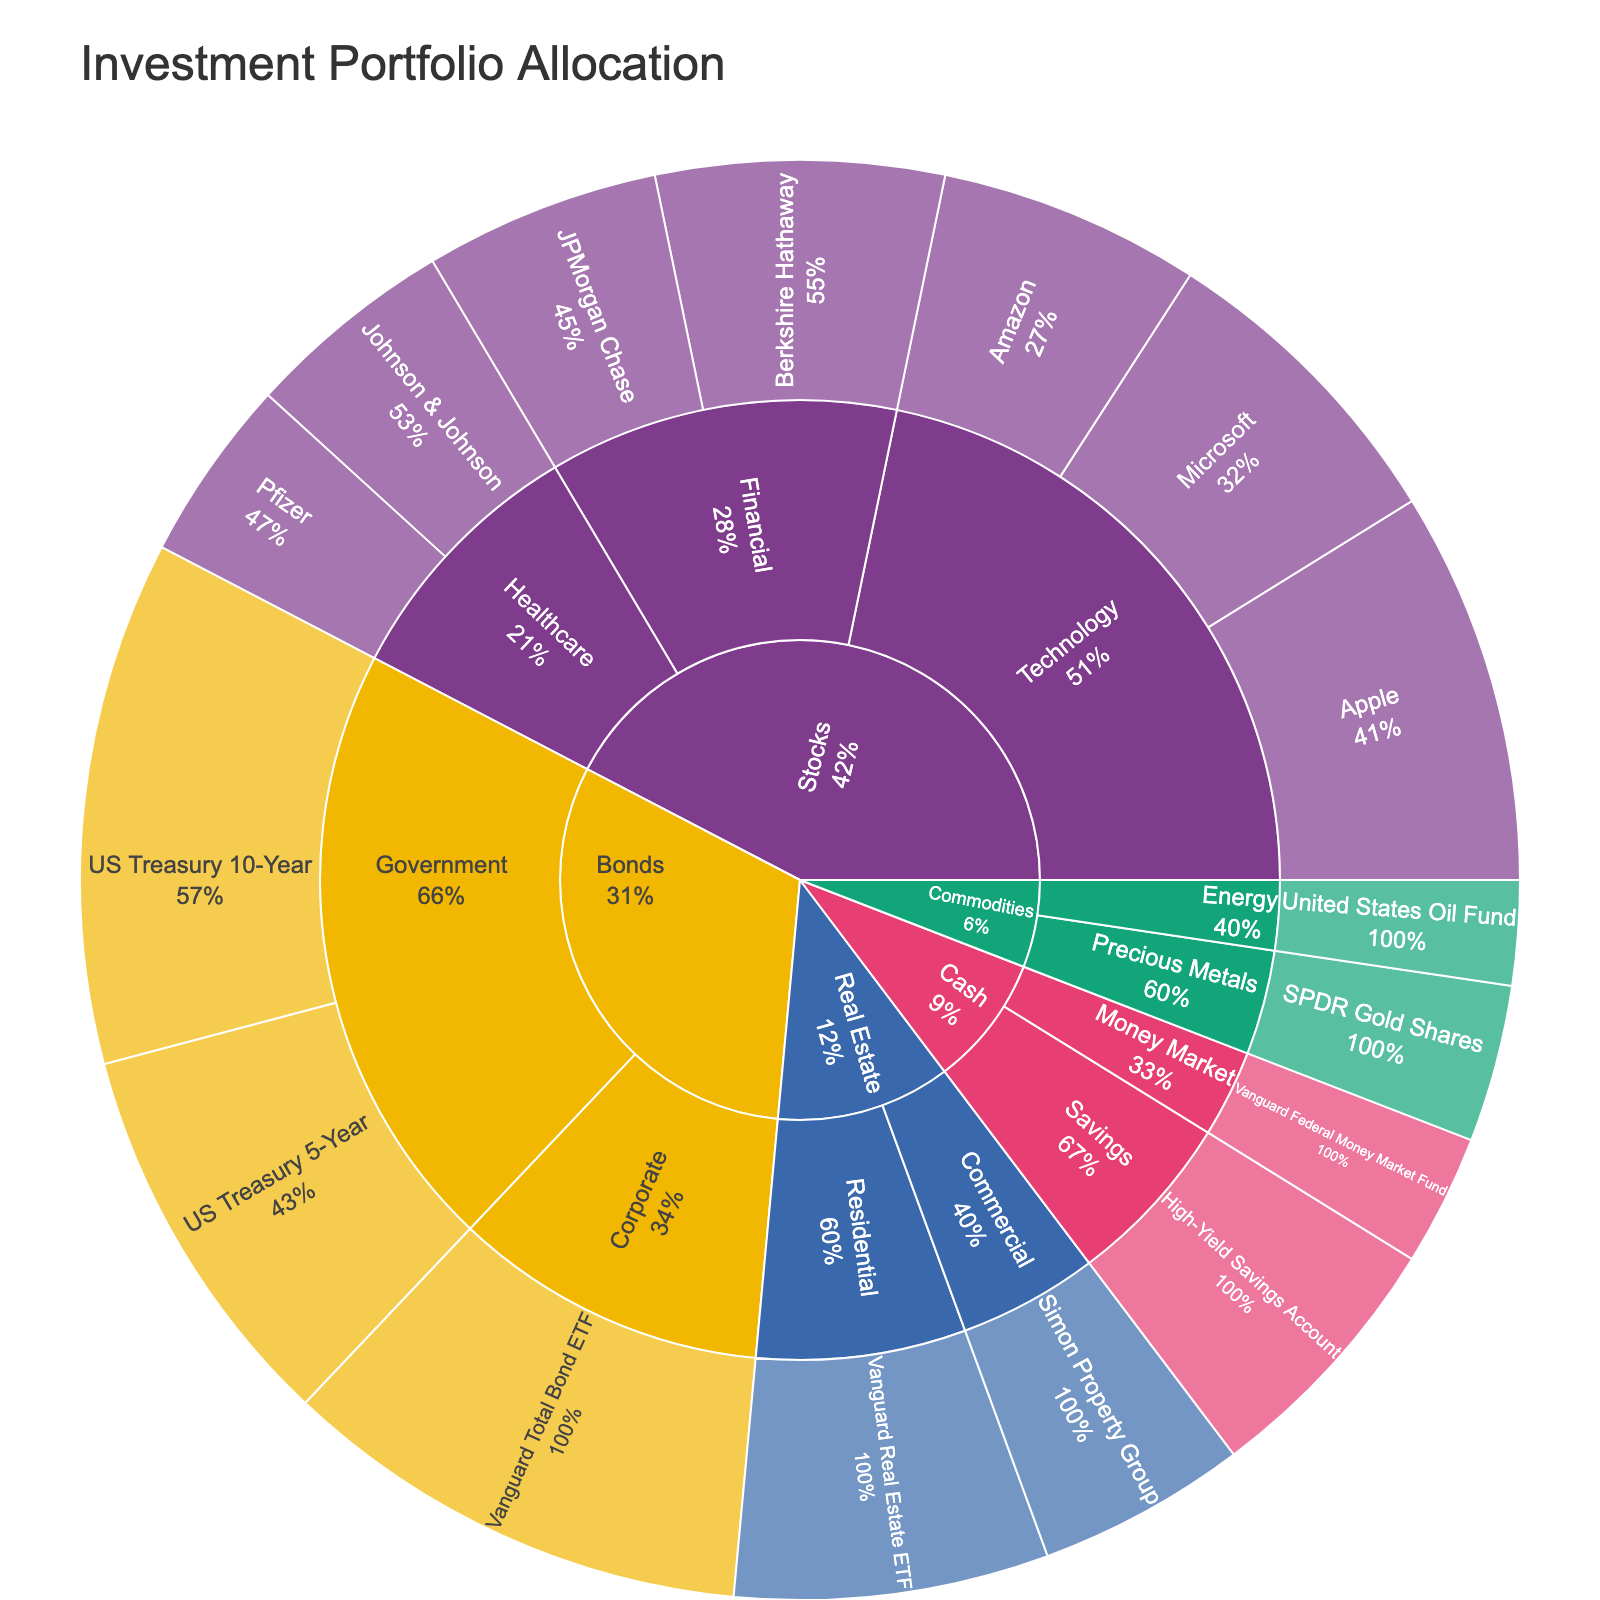What's the total value allocated to the Technology sector? Add up the values of Apple, Microsoft, and Amazon in the Technology sector. Apple (15000) + Microsoft (12000) + Amazon (10000) = 37000
Answer: 37000 Which sector within the Stocks asset class has the highest value? Compare the total values of each sector within the Stocks asset class: Technology (37000), Healthcare (15000), and Financial (20000). Technology has the highest value.
Answer: Technology What is the percentage of the entire portfolio allocated to Real Estate? Sum the values of all asset classes to get the total portfolio value. Then sum the values of Residential and Commercial sectors in Real Estate. Finally, divide the Real Estate total by the portfolio total and multiply by 100 to get the percentage. (15000 + 12000 + 10000 + 8000 + 7000 + 9000 + 11000 + 20000 + 15000 + 18000 + 12000 + 8000 + 6000 + 4000 + 10000 + 5000) = 189000; Real Estate = 12000 + 8000 = 20000; (20000/189000)*100 ≈ 10.6%
Answer: 10.6% Does the value allocated to Commodities exceed that of Healthcare? Compare the total values of Commodities and Healthcare. Commodities: Precious Metals (6000) + Energy (4000) = 10000, Healthcare: Johnson & Johnson (8000) + Pfizer (7000) = 15000. Commodities does not exceed Healthcare.
Answer: No Which individual holding has the highest value in the portfolio? Look at all individual holdings and identify the one with the highest value. US Treasury 10-Year has the highest value of 20000.
Answer: US Treasury 10-Year What is the value difference between JPMorgan Chase and Berkshire Hathaway? Subtract the value of JPMorgan Chase from Berkshire Hathaway. 11000 - 9000 = 2000
Answer: 2000 How many holdings are there in the Bonds asset class? Count the number of individual holdings in the Bonds asset class. US Treasury 10-Year, US Treasury 5-Year, Vanguard Total Bond ETF. There are 3 holdings.
Answer: 3 How does the allocation to Gold compare to the allocation to Oil? Compare the values of SPDR Gold Shares (6000) and United States Oil Fund (4000). Gold (6000) is greater than Oil (4000).
Answer: Gold is greater What is the total value allocated to Cash? Sum the values of High-Yield Savings Account and Vanguard Federal Money Market Fund in the Cash asset class. High-Yield Savings Account (10000) + Vanguard Federal Money Market Fund (5000) = 15000
Answer: 15000 What percentage of the Financial sector within the Stocks asset class is allocated to Berkshire Hathaway? Divide Berkshire Hathaway's value by the total value of the Financial sector and multiply by 100. Berkshire Hathaway (11000) / Financial sector (20000) * 100 ≈ 55%
Answer: 55% 